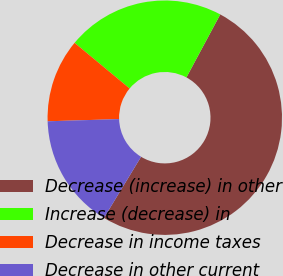Convert chart to OTSL. <chart><loc_0><loc_0><loc_500><loc_500><pie_chart><fcel>Decrease (increase) in other<fcel>Increase (decrease) in<fcel>Decrease in income taxes<fcel>Decrease in other current<nl><fcel>50.84%<fcel>21.82%<fcel>11.51%<fcel>15.83%<nl></chart> 